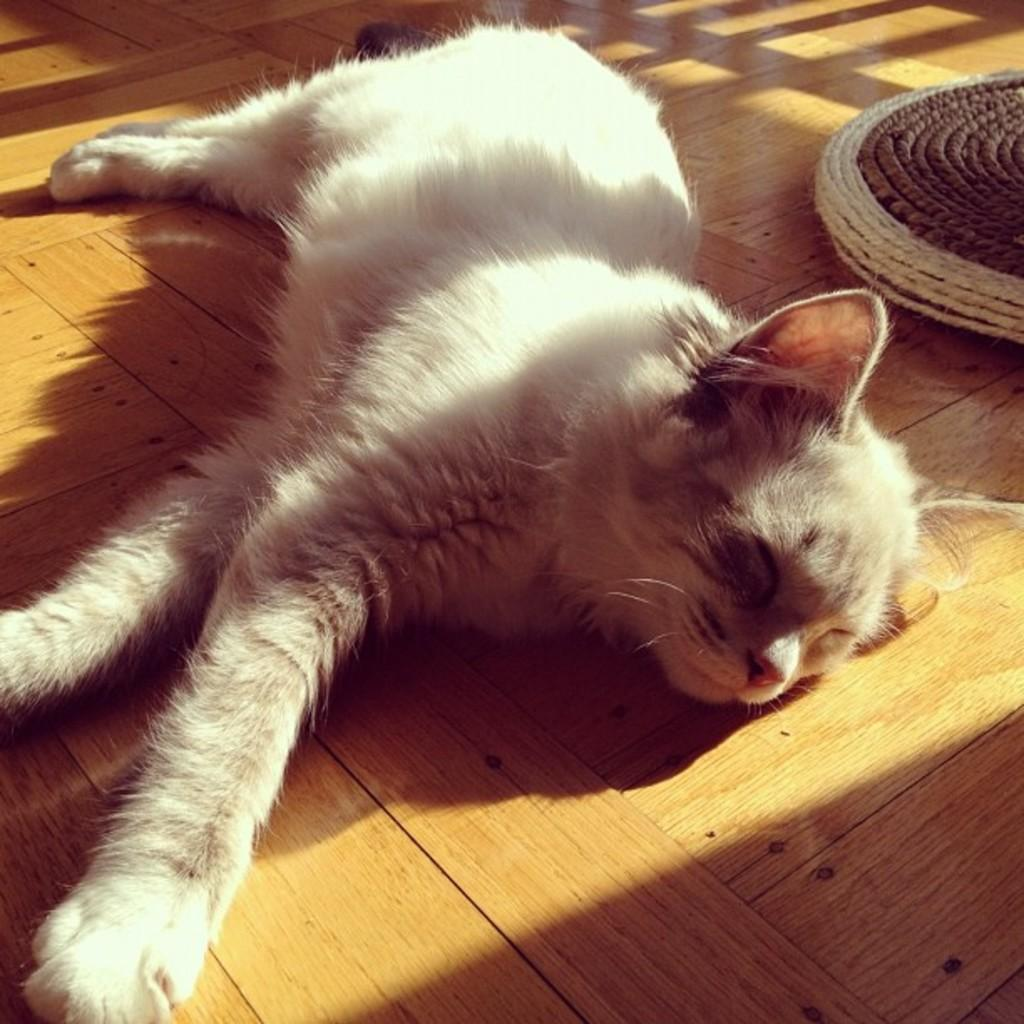What type of animal is in the image? There is a cat in the image. What is the cat doing in the image? The cat is sleeping. What type of surface is the cat resting on? The cat is on a wooden floor. What else can be seen on the wooden floor in the image? There are objects on the wooden floor. What type of religious symbol can be seen on the cat's forehead in the image? There is no religious symbol present on the cat's forehead in the image. 